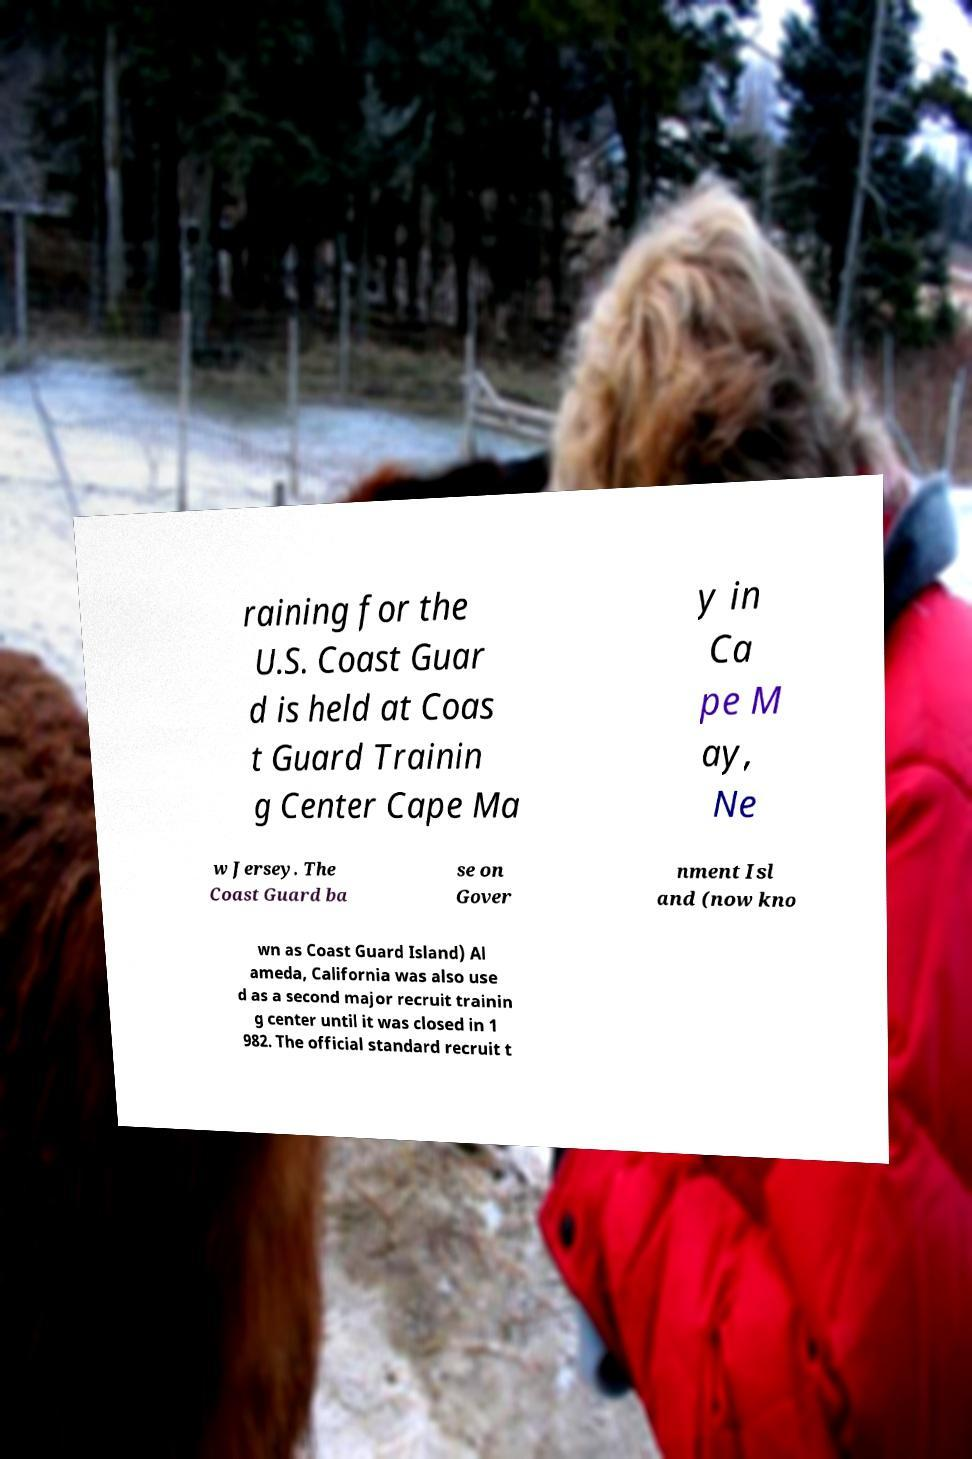Could you extract and type out the text from this image? raining for the U.S. Coast Guar d is held at Coas t Guard Trainin g Center Cape Ma y in Ca pe M ay, Ne w Jersey. The Coast Guard ba se on Gover nment Isl and (now kno wn as Coast Guard Island) Al ameda, California was also use d as a second major recruit trainin g center until it was closed in 1 982. The official standard recruit t 